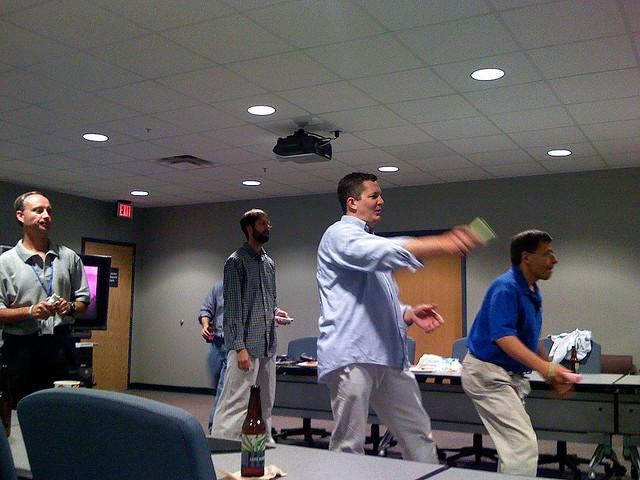What is everyone doing standing with remotes?

Choices:
A) changing television
B) power point
C) video gaming
D) calisthenics video gaming 